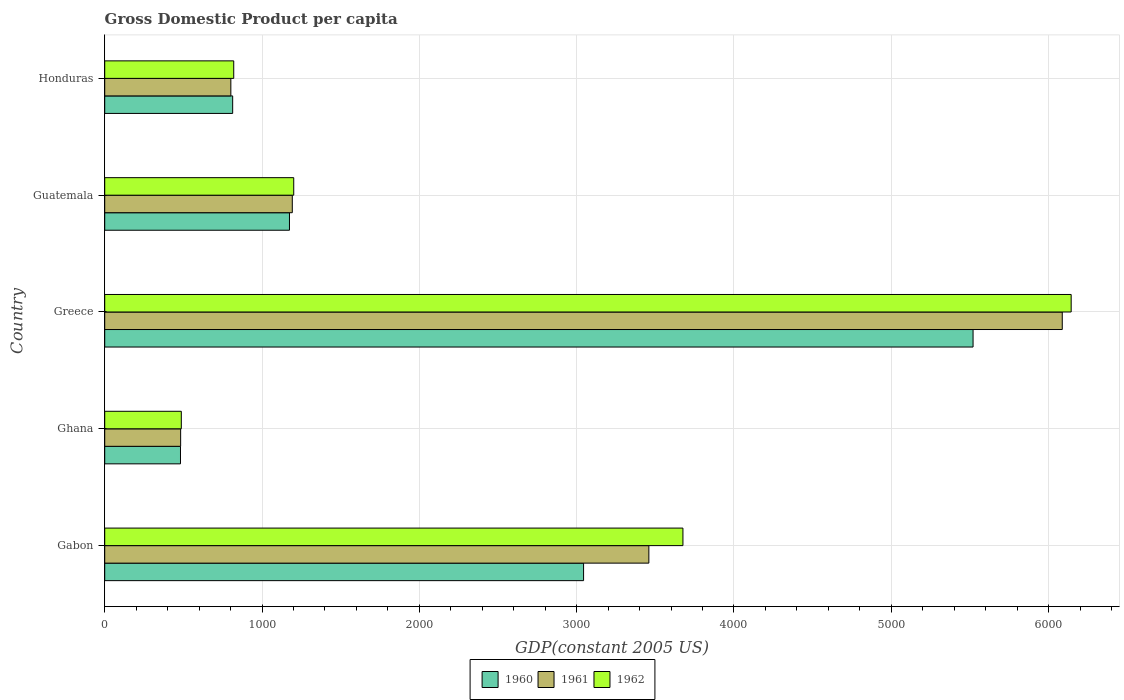How many different coloured bars are there?
Your response must be concise. 3. Are the number of bars per tick equal to the number of legend labels?
Your answer should be compact. Yes. Are the number of bars on each tick of the Y-axis equal?
Ensure brevity in your answer.  Yes. How many bars are there on the 1st tick from the bottom?
Provide a succinct answer. 3. What is the label of the 1st group of bars from the top?
Your answer should be very brief. Honduras. In how many cases, is the number of bars for a given country not equal to the number of legend labels?
Keep it short and to the point. 0. What is the GDP per capita in 1960 in Ghana?
Your answer should be very brief. 481.62. Across all countries, what is the maximum GDP per capita in 1960?
Your answer should be compact. 5520.09. Across all countries, what is the minimum GDP per capita in 1961?
Provide a short and direct response. 482.59. What is the total GDP per capita in 1961 in the graph?
Make the answer very short. 1.20e+04. What is the difference between the GDP per capita in 1960 in Ghana and that in Honduras?
Make the answer very short. -331.79. What is the difference between the GDP per capita in 1962 in Greece and the GDP per capita in 1961 in Honduras?
Your answer should be compact. 5341.96. What is the average GDP per capita in 1962 per country?
Keep it short and to the point. 2465.63. What is the difference between the GDP per capita in 1961 and GDP per capita in 1962 in Greece?
Provide a succinct answer. -56.63. In how many countries, is the GDP per capita in 1962 greater than 2600 US$?
Your response must be concise. 2. What is the ratio of the GDP per capita in 1961 in Gabon to that in Guatemala?
Provide a short and direct response. 2.9. Is the GDP per capita in 1961 in Gabon less than that in Ghana?
Offer a terse response. No. What is the difference between the highest and the second highest GDP per capita in 1962?
Provide a succinct answer. 2467.97. What is the difference between the highest and the lowest GDP per capita in 1962?
Offer a terse response. 5656.83. In how many countries, is the GDP per capita in 1961 greater than the average GDP per capita in 1961 taken over all countries?
Provide a short and direct response. 2. What does the 2nd bar from the top in Gabon represents?
Provide a succinct answer. 1961. Is it the case that in every country, the sum of the GDP per capita in 1961 and GDP per capita in 1960 is greater than the GDP per capita in 1962?
Make the answer very short. Yes. Are all the bars in the graph horizontal?
Your answer should be very brief. Yes. Are the values on the major ticks of X-axis written in scientific E-notation?
Make the answer very short. No. Does the graph contain any zero values?
Provide a succinct answer. No. Does the graph contain grids?
Provide a succinct answer. Yes. Where does the legend appear in the graph?
Provide a succinct answer. Bottom center. How are the legend labels stacked?
Provide a short and direct response. Horizontal. What is the title of the graph?
Give a very brief answer. Gross Domestic Product per capita. What is the label or title of the X-axis?
Your answer should be very brief. GDP(constant 2005 US). What is the label or title of the Y-axis?
Offer a terse response. Country. What is the GDP(constant 2005 US) of 1960 in Gabon?
Provide a short and direct response. 3044.16. What is the GDP(constant 2005 US) of 1961 in Gabon?
Offer a terse response. 3459.15. What is the GDP(constant 2005 US) of 1962 in Gabon?
Offer a very short reply. 3675.76. What is the GDP(constant 2005 US) in 1960 in Ghana?
Provide a succinct answer. 481.62. What is the GDP(constant 2005 US) of 1961 in Ghana?
Keep it short and to the point. 482.59. What is the GDP(constant 2005 US) of 1962 in Ghana?
Make the answer very short. 486.9. What is the GDP(constant 2005 US) in 1960 in Greece?
Offer a very short reply. 5520.09. What is the GDP(constant 2005 US) in 1961 in Greece?
Keep it short and to the point. 6087.1. What is the GDP(constant 2005 US) of 1962 in Greece?
Offer a terse response. 6143.73. What is the GDP(constant 2005 US) in 1960 in Guatemala?
Give a very brief answer. 1174.44. What is the GDP(constant 2005 US) of 1961 in Guatemala?
Offer a terse response. 1192.42. What is the GDP(constant 2005 US) in 1962 in Guatemala?
Give a very brief answer. 1201.57. What is the GDP(constant 2005 US) of 1960 in Honduras?
Make the answer very short. 813.41. What is the GDP(constant 2005 US) in 1961 in Honduras?
Keep it short and to the point. 801.77. What is the GDP(constant 2005 US) in 1962 in Honduras?
Give a very brief answer. 820.2. Across all countries, what is the maximum GDP(constant 2005 US) of 1960?
Your response must be concise. 5520.09. Across all countries, what is the maximum GDP(constant 2005 US) in 1961?
Your answer should be compact. 6087.1. Across all countries, what is the maximum GDP(constant 2005 US) in 1962?
Your answer should be very brief. 6143.73. Across all countries, what is the minimum GDP(constant 2005 US) of 1960?
Keep it short and to the point. 481.62. Across all countries, what is the minimum GDP(constant 2005 US) of 1961?
Provide a succinct answer. 482.59. Across all countries, what is the minimum GDP(constant 2005 US) in 1962?
Give a very brief answer. 486.9. What is the total GDP(constant 2005 US) in 1960 in the graph?
Provide a short and direct response. 1.10e+04. What is the total GDP(constant 2005 US) of 1961 in the graph?
Give a very brief answer. 1.20e+04. What is the total GDP(constant 2005 US) in 1962 in the graph?
Your response must be concise. 1.23e+04. What is the difference between the GDP(constant 2005 US) of 1960 in Gabon and that in Ghana?
Your response must be concise. 2562.54. What is the difference between the GDP(constant 2005 US) in 1961 in Gabon and that in Ghana?
Your answer should be compact. 2976.55. What is the difference between the GDP(constant 2005 US) of 1962 in Gabon and that in Ghana?
Give a very brief answer. 3188.86. What is the difference between the GDP(constant 2005 US) of 1960 in Gabon and that in Greece?
Provide a succinct answer. -2475.93. What is the difference between the GDP(constant 2005 US) in 1961 in Gabon and that in Greece?
Offer a very short reply. -2627.95. What is the difference between the GDP(constant 2005 US) in 1962 in Gabon and that in Greece?
Your answer should be compact. -2467.97. What is the difference between the GDP(constant 2005 US) of 1960 in Gabon and that in Guatemala?
Make the answer very short. 1869.72. What is the difference between the GDP(constant 2005 US) of 1961 in Gabon and that in Guatemala?
Your response must be concise. 2266.73. What is the difference between the GDP(constant 2005 US) in 1962 in Gabon and that in Guatemala?
Provide a short and direct response. 2474.19. What is the difference between the GDP(constant 2005 US) in 1960 in Gabon and that in Honduras?
Make the answer very short. 2230.75. What is the difference between the GDP(constant 2005 US) of 1961 in Gabon and that in Honduras?
Your answer should be very brief. 2657.37. What is the difference between the GDP(constant 2005 US) of 1962 in Gabon and that in Honduras?
Ensure brevity in your answer.  2855.56. What is the difference between the GDP(constant 2005 US) of 1960 in Ghana and that in Greece?
Offer a very short reply. -5038.47. What is the difference between the GDP(constant 2005 US) in 1961 in Ghana and that in Greece?
Ensure brevity in your answer.  -5604.5. What is the difference between the GDP(constant 2005 US) in 1962 in Ghana and that in Greece?
Offer a terse response. -5656.83. What is the difference between the GDP(constant 2005 US) in 1960 in Ghana and that in Guatemala?
Ensure brevity in your answer.  -692.82. What is the difference between the GDP(constant 2005 US) in 1961 in Ghana and that in Guatemala?
Offer a terse response. -709.82. What is the difference between the GDP(constant 2005 US) of 1962 in Ghana and that in Guatemala?
Offer a terse response. -714.67. What is the difference between the GDP(constant 2005 US) of 1960 in Ghana and that in Honduras?
Offer a terse response. -331.79. What is the difference between the GDP(constant 2005 US) in 1961 in Ghana and that in Honduras?
Make the answer very short. -319.18. What is the difference between the GDP(constant 2005 US) in 1962 in Ghana and that in Honduras?
Your answer should be compact. -333.3. What is the difference between the GDP(constant 2005 US) of 1960 in Greece and that in Guatemala?
Keep it short and to the point. 4345.65. What is the difference between the GDP(constant 2005 US) of 1961 in Greece and that in Guatemala?
Ensure brevity in your answer.  4894.68. What is the difference between the GDP(constant 2005 US) of 1962 in Greece and that in Guatemala?
Make the answer very short. 4942.16. What is the difference between the GDP(constant 2005 US) of 1960 in Greece and that in Honduras?
Ensure brevity in your answer.  4706.68. What is the difference between the GDP(constant 2005 US) in 1961 in Greece and that in Honduras?
Offer a very short reply. 5285.32. What is the difference between the GDP(constant 2005 US) of 1962 in Greece and that in Honduras?
Give a very brief answer. 5323.53. What is the difference between the GDP(constant 2005 US) in 1960 in Guatemala and that in Honduras?
Your response must be concise. 361.03. What is the difference between the GDP(constant 2005 US) in 1961 in Guatemala and that in Honduras?
Provide a short and direct response. 390.64. What is the difference between the GDP(constant 2005 US) in 1962 in Guatemala and that in Honduras?
Keep it short and to the point. 381.38. What is the difference between the GDP(constant 2005 US) in 1960 in Gabon and the GDP(constant 2005 US) in 1961 in Ghana?
Make the answer very short. 2561.57. What is the difference between the GDP(constant 2005 US) in 1960 in Gabon and the GDP(constant 2005 US) in 1962 in Ghana?
Make the answer very short. 2557.26. What is the difference between the GDP(constant 2005 US) in 1961 in Gabon and the GDP(constant 2005 US) in 1962 in Ghana?
Offer a very short reply. 2972.24. What is the difference between the GDP(constant 2005 US) in 1960 in Gabon and the GDP(constant 2005 US) in 1961 in Greece?
Offer a very short reply. -3042.93. What is the difference between the GDP(constant 2005 US) in 1960 in Gabon and the GDP(constant 2005 US) in 1962 in Greece?
Ensure brevity in your answer.  -3099.57. What is the difference between the GDP(constant 2005 US) in 1961 in Gabon and the GDP(constant 2005 US) in 1962 in Greece?
Provide a short and direct response. -2684.59. What is the difference between the GDP(constant 2005 US) in 1960 in Gabon and the GDP(constant 2005 US) in 1961 in Guatemala?
Offer a very short reply. 1851.75. What is the difference between the GDP(constant 2005 US) in 1960 in Gabon and the GDP(constant 2005 US) in 1962 in Guatemala?
Offer a terse response. 1842.59. What is the difference between the GDP(constant 2005 US) of 1961 in Gabon and the GDP(constant 2005 US) of 1962 in Guatemala?
Your answer should be very brief. 2257.57. What is the difference between the GDP(constant 2005 US) of 1960 in Gabon and the GDP(constant 2005 US) of 1961 in Honduras?
Offer a terse response. 2242.39. What is the difference between the GDP(constant 2005 US) of 1960 in Gabon and the GDP(constant 2005 US) of 1962 in Honduras?
Offer a terse response. 2223.96. What is the difference between the GDP(constant 2005 US) of 1961 in Gabon and the GDP(constant 2005 US) of 1962 in Honduras?
Keep it short and to the point. 2638.95. What is the difference between the GDP(constant 2005 US) in 1960 in Ghana and the GDP(constant 2005 US) in 1961 in Greece?
Make the answer very short. -5605.48. What is the difference between the GDP(constant 2005 US) of 1960 in Ghana and the GDP(constant 2005 US) of 1962 in Greece?
Offer a terse response. -5662.11. What is the difference between the GDP(constant 2005 US) in 1961 in Ghana and the GDP(constant 2005 US) in 1962 in Greece?
Keep it short and to the point. -5661.14. What is the difference between the GDP(constant 2005 US) of 1960 in Ghana and the GDP(constant 2005 US) of 1961 in Guatemala?
Your answer should be very brief. -710.8. What is the difference between the GDP(constant 2005 US) of 1960 in Ghana and the GDP(constant 2005 US) of 1962 in Guatemala?
Provide a succinct answer. -719.96. What is the difference between the GDP(constant 2005 US) of 1961 in Ghana and the GDP(constant 2005 US) of 1962 in Guatemala?
Your answer should be compact. -718.98. What is the difference between the GDP(constant 2005 US) of 1960 in Ghana and the GDP(constant 2005 US) of 1961 in Honduras?
Offer a very short reply. -320.16. What is the difference between the GDP(constant 2005 US) in 1960 in Ghana and the GDP(constant 2005 US) in 1962 in Honduras?
Make the answer very short. -338.58. What is the difference between the GDP(constant 2005 US) in 1961 in Ghana and the GDP(constant 2005 US) in 1962 in Honduras?
Provide a short and direct response. -337.61. What is the difference between the GDP(constant 2005 US) in 1960 in Greece and the GDP(constant 2005 US) in 1961 in Guatemala?
Your answer should be compact. 4327.67. What is the difference between the GDP(constant 2005 US) of 1960 in Greece and the GDP(constant 2005 US) of 1962 in Guatemala?
Provide a short and direct response. 4318.51. What is the difference between the GDP(constant 2005 US) in 1961 in Greece and the GDP(constant 2005 US) in 1962 in Guatemala?
Your answer should be compact. 4885.52. What is the difference between the GDP(constant 2005 US) in 1960 in Greece and the GDP(constant 2005 US) in 1961 in Honduras?
Provide a succinct answer. 4718.31. What is the difference between the GDP(constant 2005 US) in 1960 in Greece and the GDP(constant 2005 US) in 1962 in Honduras?
Keep it short and to the point. 4699.89. What is the difference between the GDP(constant 2005 US) of 1961 in Greece and the GDP(constant 2005 US) of 1962 in Honduras?
Ensure brevity in your answer.  5266.9. What is the difference between the GDP(constant 2005 US) of 1960 in Guatemala and the GDP(constant 2005 US) of 1961 in Honduras?
Your answer should be very brief. 372.67. What is the difference between the GDP(constant 2005 US) of 1960 in Guatemala and the GDP(constant 2005 US) of 1962 in Honduras?
Offer a terse response. 354.24. What is the difference between the GDP(constant 2005 US) in 1961 in Guatemala and the GDP(constant 2005 US) in 1962 in Honduras?
Your response must be concise. 372.22. What is the average GDP(constant 2005 US) in 1960 per country?
Your answer should be compact. 2206.74. What is the average GDP(constant 2005 US) in 1961 per country?
Ensure brevity in your answer.  2404.61. What is the average GDP(constant 2005 US) in 1962 per country?
Your answer should be very brief. 2465.63. What is the difference between the GDP(constant 2005 US) in 1960 and GDP(constant 2005 US) in 1961 in Gabon?
Keep it short and to the point. -414.98. What is the difference between the GDP(constant 2005 US) in 1960 and GDP(constant 2005 US) in 1962 in Gabon?
Ensure brevity in your answer.  -631.6. What is the difference between the GDP(constant 2005 US) in 1961 and GDP(constant 2005 US) in 1962 in Gabon?
Your answer should be compact. -216.62. What is the difference between the GDP(constant 2005 US) in 1960 and GDP(constant 2005 US) in 1961 in Ghana?
Offer a very short reply. -0.97. What is the difference between the GDP(constant 2005 US) in 1960 and GDP(constant 2005 US) in 1962 in Ghana?
Offer a very short reply. -5.28. What is the difference between the GDP(constant 2005 US) in 1961 and GDP(constant 2005 US) in 1962 in Ghana?
Offer a terse response. -4.31. What is the difference between the GDP(constant 2005 US) of 1960 and GDP(constant 2005 US) of 1961 in Greece?
Offer a very short reply. -567.01. What is the difference between the GDP(constant 2005 US) in 1960 and GDP(constant 2005 US) in 1962 in Greece?
Your answer should be very brief. -623.64. What is the difference between the GDP(constant 2005 US) of 1961 and GDP(constant 2005 US) of 1962 in Greece?
Give a very brief answer. -56.63. What is the difference between the GDP(constant 2005 US) in 1960 and GDP(constant 2005 US) in 1961 in Guatemala?
Provide a short and direct response. -17.97. What is the difference between the GDP(constant 2005 US) of 1960 and GDP(constant 2005 US) of 1962 in Guatemala?
Ensure brevity in your answer.  -27.13. What is the difference between the GDP(constant 2005 US) in 1961 and GDP(constant 2005 US) in 1962 in Guatemala?
Your answer should be compact. -9.16. What is the difference between the GDP(constant 2005 US) in 1960 and GDP(constant 2005 US) in 1961 in Honduras?
Your response must be concise. 11.63. What is the difference between the GDP(constant 2005 US) of 1960 and GDP(constant 2005 US) of 1962 in Honduras?
Your answer should be compact. -6.79. What is the difference between the GDP(constant 2005 US) in 1961 and GDP(constant 2005 US) in 1962 in Honduras?
Your answer should be very brief. -18.42. What is the ratio of the GDP(constant 2005 US) of 1960 in Gabon to that in Ghana?
Provide a succinct answer. 6.32. What is the ratio of the GDP(constant 2005 US) in 1961 in Gabon to that in Ghana?
Provide a short and direct response. 7.17. What is the ratio of the GDP(constant 2005 US) of 1962 in Gabon to that in Ghana?
Give a very brief answer. 7.55. What is the ratio of the GDP(constant 2005 US) of 1960 in Gabon to that in Greece?
Offer a very short reply. 0.55. What is the ratio of the GDP(constant 2005 US) of 1961 in Gabon to that in Greece?
Offer a terse response. 0.57. What is the ratio of the GDP(constant 2005 US) of 1962 in Gabon to that in Greece?
Make the answer very short. 0.6. What is the ratio of the GDP(constant 2005 US) in 1960 in Gabon to that in Guatemala?
Offer a terse response. 2.59. What is the ratio of the GDP(constant 2005 US) of 1961 in Gabon to that in Guatemala?
Make the answer very short. 2.9. What is the ratio of the GDP(constant 2005 US) of 1962 in Gabon to that in Guatemala?
Your answer should be very brief. 3.06. What is the ratio of the GDP(constant 2005 US) in 1960 in Gabon to that in Honduras?
Keep it short and to the point. 3.74. What is the ratio of the GDP(constant 2005 US) in 1961 in Gabon to that in Honduras?
Your response must be concise. 4.31. What is the ratio of the GDP(constant 2005 US) in 1962 in Gabon to that in Honduras?
Offer a very short reply. 4.48. What is the ratio of the GDP(constant 2005 US) of 1960 in Ghana to that in Greece?
Ensure brevity in your answer.  0.09. What is the ratio of the GDP(constant 2005 US) of 1961 in Ghana to that in Greece?
Give a very brief answer. 0.08. What is the ratio of the GDP(constant 2005 US) in 1962 in Ghana to that in Greece?
Your answer should be compact. 0.08. What is the ratio of the GDP(constant 2005 US) of 1960 in Ghana to that in Guatemala?
Your answer should be compact. 0.41. What is the ratio of the GDP(constant 2005 US) in 1961 in Ghana to that in Guatemala?
Provide a succinct answer. 0.4. What is the ratio of the GDP(constant 2005 US) of 1962 in Ghana to that in Guatemala?
Offer a very short reply. 0.41. What is the ratio of the GDP(constant 2005 US) of 1960 in Ghana to that in Honduras?
Your answer should be very brief. 0.59. What is the ratio of the GDP(constant 2005 US) of 1961 in Ghana to that in Honduras?
Make the answer very short. 0.6. What is the ratio of the GDP(constant 2005 US) of 1962 in Ghana to that in Honduras?
Make the answer very short. 0.59. What is the ratio of the GDP(constant 2005 US) in 1960 in Greece to that in Guatemala?
Keep it short and to the point. 4.7. What is the ratio of the GDP(constant 2005 US) of 1961 in Greece to that in Guatemala?
Your answer should be very brief. 5.1. What is the ratio of the GDP(constant 2005 US) in 1962 in Greece to that in Guatemala?
Give a very brief answer. 5.11. What is the ratio of the GDP(constant 2005 US) in 1960 in Greece to that in Honduras?
Give a very brief answer. 6.79. What is the ratio of the GDP(constant 2005 US) of 1961 in Greece to that in Honduras?
Give a very brief answer. 7.59. What is the ratio of the GDP(constant 2005 US) of 1962 in Greece to that in Honduras?
Provide a succinct answer. 7.49. What is the ratio of the GDP(constant 2005 US) in 1960 in Guatemala to that in Honduras?
Provide a short and direct response. 1.44. What is the ratio of the GDP(constant 2005 US) of 1961 in Guatemala to that in Honduras?
Provide a succinct answer. 1.49. What is the ratio of the GDP(constant 2005 US) in 1962 in Guatemala to that in Honduras?
Make the answer very short. 1.47. What is the difference between the highest and the second highest GDP(constant 2005 US) in 1960?
Keep it short and to the point. 2475.93. What is the difference between the highest and the second highest GDP(constant 2005 US) in 1961?
Offer a very short reply. 2627.95. What is the difference between the highest and the second highest GDP(constant 2005 US) in 1962?
Make the answer very short. 2467.97. What is the difference between the highest and the lowest GDP(constant 2005 US) of 1960?
Provide a short and direct response. 5038.47. What is the difference between the highest and the lowest GDP(constant 2005 US) of 1961?
Give a very brief answer. 5604.5. What is the difference between the highest and the lowest GDP(constant 2005 US) of 1962?
Your answer should be very brief. 5656.83. 